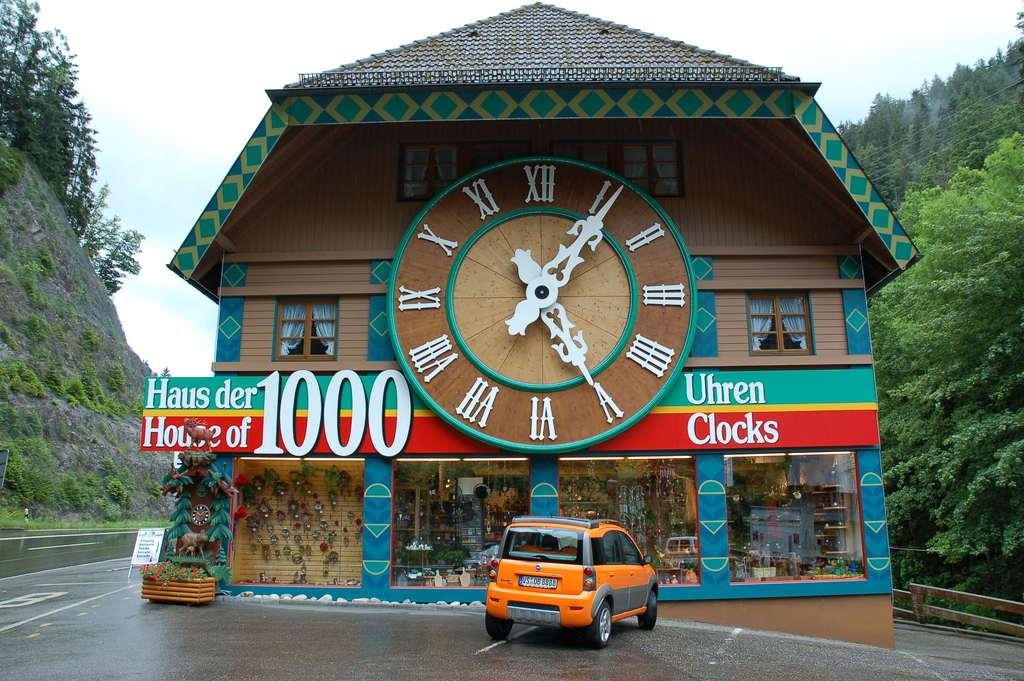<image>
Relay a brief, clear account of the picture shown. An old looking brown building has a large clock in the front center of the establishment with the name House of 1000 clocks written in both English and German. 